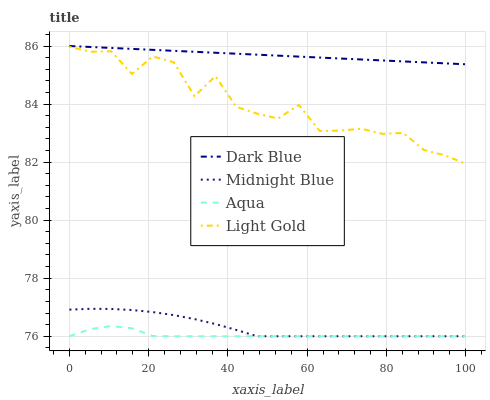Does Aqua have the minimum area under the curve?
Answer yes or no. Yes. Does Dark Blue have the maximum area under the curve?
Answer yes or no. Yes. Does Light Gold have the minimum area under the curve?
Answer yes or no. No. Does Light Gold have the maximum area under the curve?
Answer yes or no. No. Is Dark Blue the smoothest?
Answer yes or no. Yes. Is Light Gold the roughest?
Answer yes or no. Yes. Is Aqua the smoothest?
Answer yes or no. No. Is Aqua the roughest?
Answer yes or no. No. Does Aqua have the lowest value?
Answer yes or no. Yes. Does Light Gold have the lowest value?
Answer yes or no. No. Does Dark Blue have the highest value?
Answer yes or no. Yes. Does Light Gold have the highest value?
Answer yes or no. No. Is Aqua less than Dark Blue?
Answer yes or no. Yes. Is Dark Blue greater than Light Gold?
Answer yes or no. Yes. Does Aqua intersect Midnight Blue?
Answer yes or no. Yes. Is Aqua less than Midnight Blue?
Answer yes or no. No. Is Aqua greater than Midnight Blue?
Answer yes or no. No. Does Aqua intersect Dark Blue?
Answer yes or no. No. 